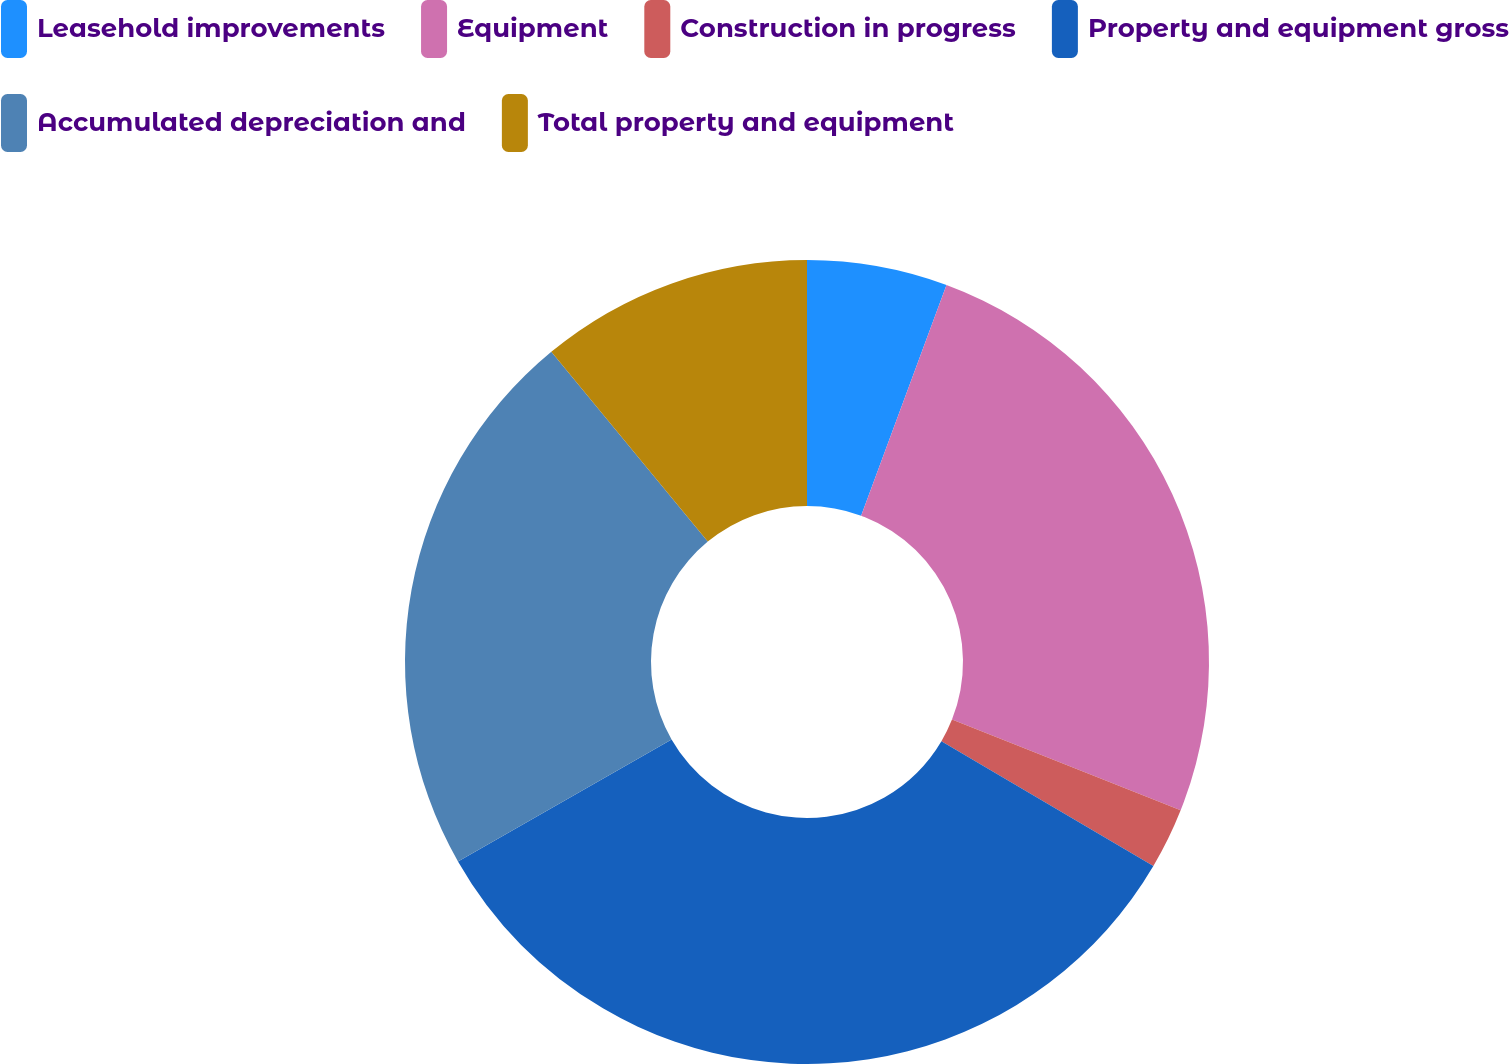Convert chart to OTSL. <chart><loc_0><loc_0><loc_500><loc_500><pie_chart><fcel>Leasehold improvements<fcel>Equipment<fcel>Construction in progress<fcel>Property and equipment gross<fcel>Accumulated depreciation and<fcel>Total property and equipment<nl><fcel>5.64%<fcel>25.37%<fcel>2.46%<fcel>33.26%<fcel>22.29%<fcel>10.97%<nl></chart> 